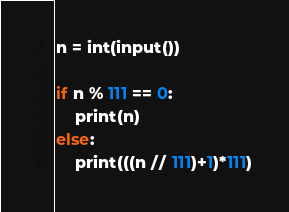<code> <loc_0><loc_0><loc_500><loc_500><_Python_>n = int(input())

if n % 111 == 0:
    print(n)
else:
    print(((n // 111)+1)*111)</code> 